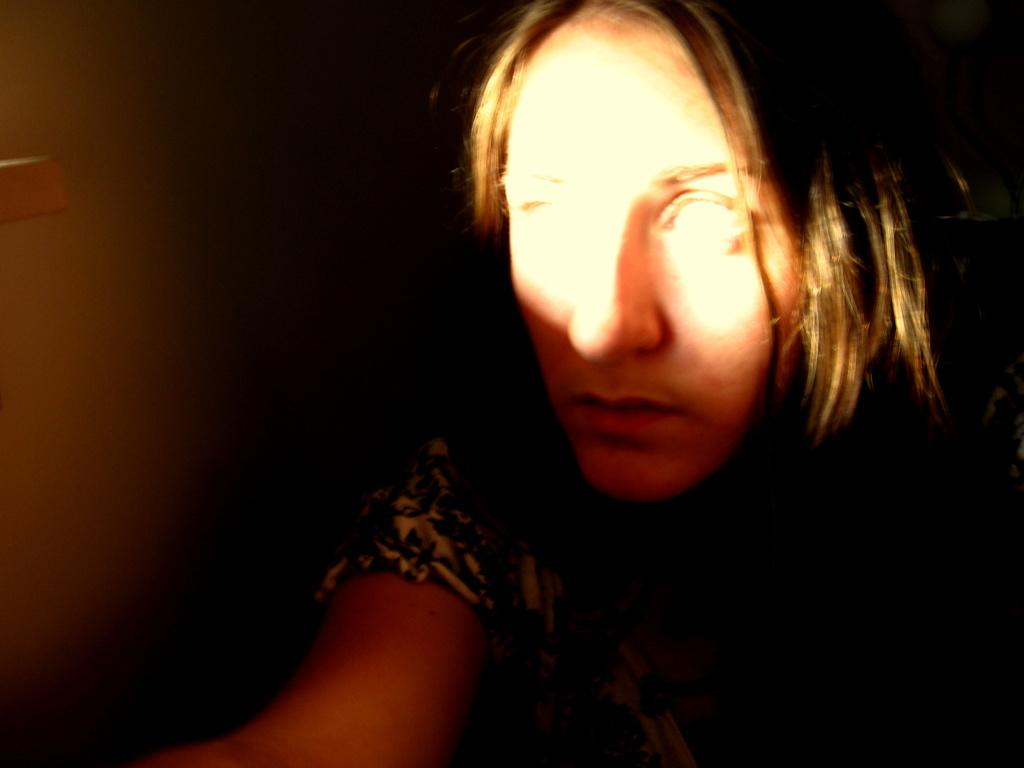What can be seen on the person's face in the image? There is light on the person's face in the image. What is visible in the background of the image? There is a wall in the background of the image. What type of government is depicted on the wall in the image? There is no government depicted on the wall in the image; it is simply a wall in the background. Is there an addition to the building visible in the image? There is no mention of an addition to the building in the provided facts, and therefore it cannot be determined from the image. 